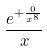<formula> <loc_0><loc_0><loc_500><loc_500>\frac { e ^ { + \frac { 0 } { x ^ { 8 } } } } { x }</formula> 